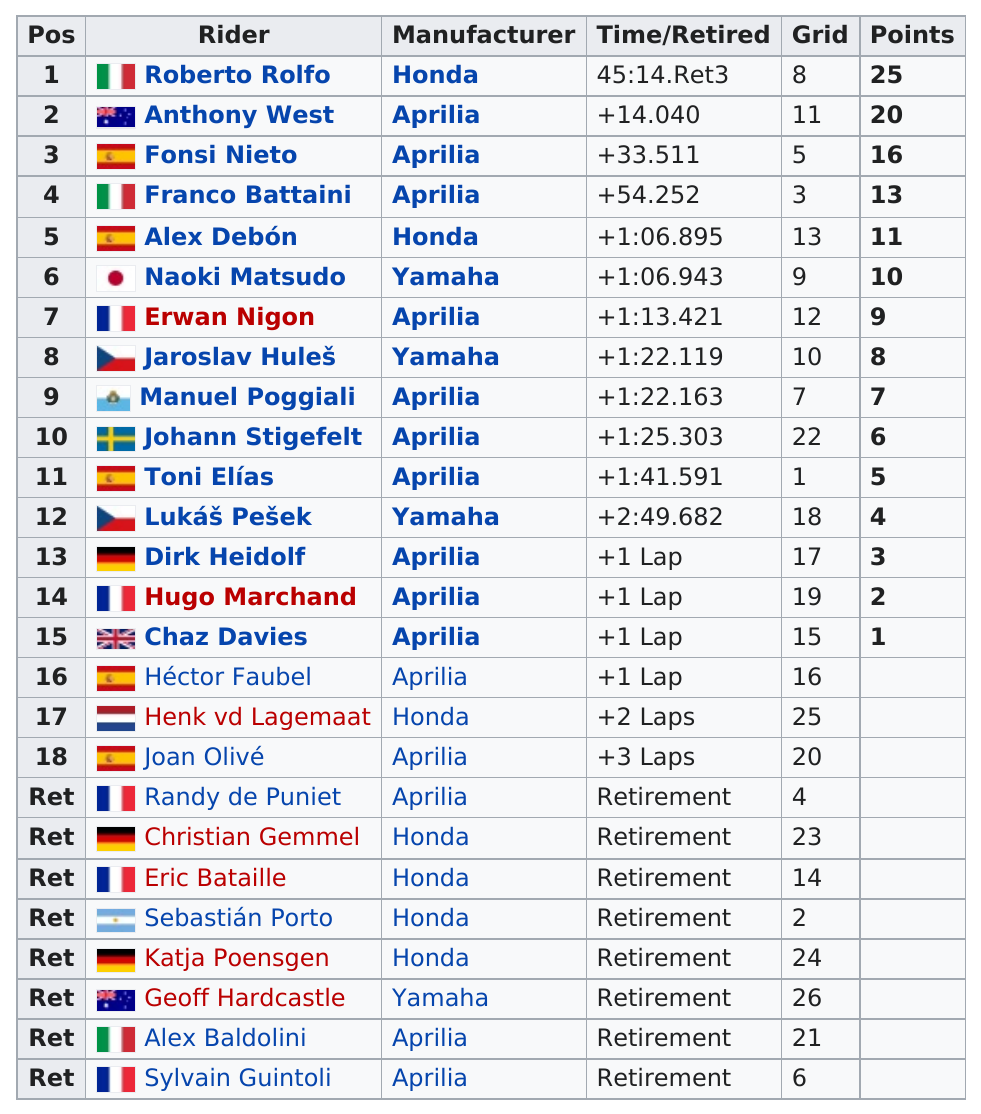Give some essential details in this illustration. The answer to the question "who received more points, Alex Debón or Toni Elias?" is Alex Debón. Anthony West rode the top-finishing Aprilia in the competition. It is known that at least two riders earned 20 or more points. Based on the information provided, a total of 15 riders participated in the 250cc class with equipment manufactured by Aprilla. Chaz Davies, who is in the top 15 positions, scored no more than 1 point, making him the rider to fulfill this criteria. 